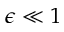<formula> <loc_0><loc_0><loc_500><loc_500>\epsilon \ll 1</formula> 